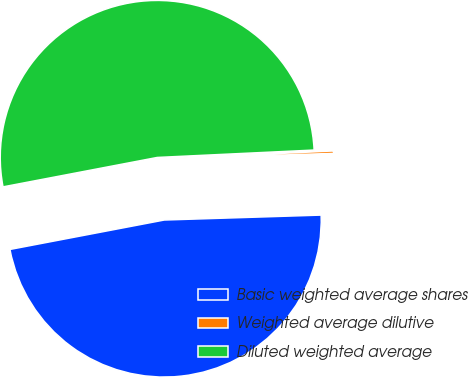Convert chart to OTSL. <chart><loc_0><loc_0><loc_500><loc_500><pie_chart><fcel>Basic weighted average shares<fcel>Weighted average dilutive<fcel>Diluted weighted average<nl><fcel>47.5%<fcel>0.25%<fcel>52.25%<nl></chart> 